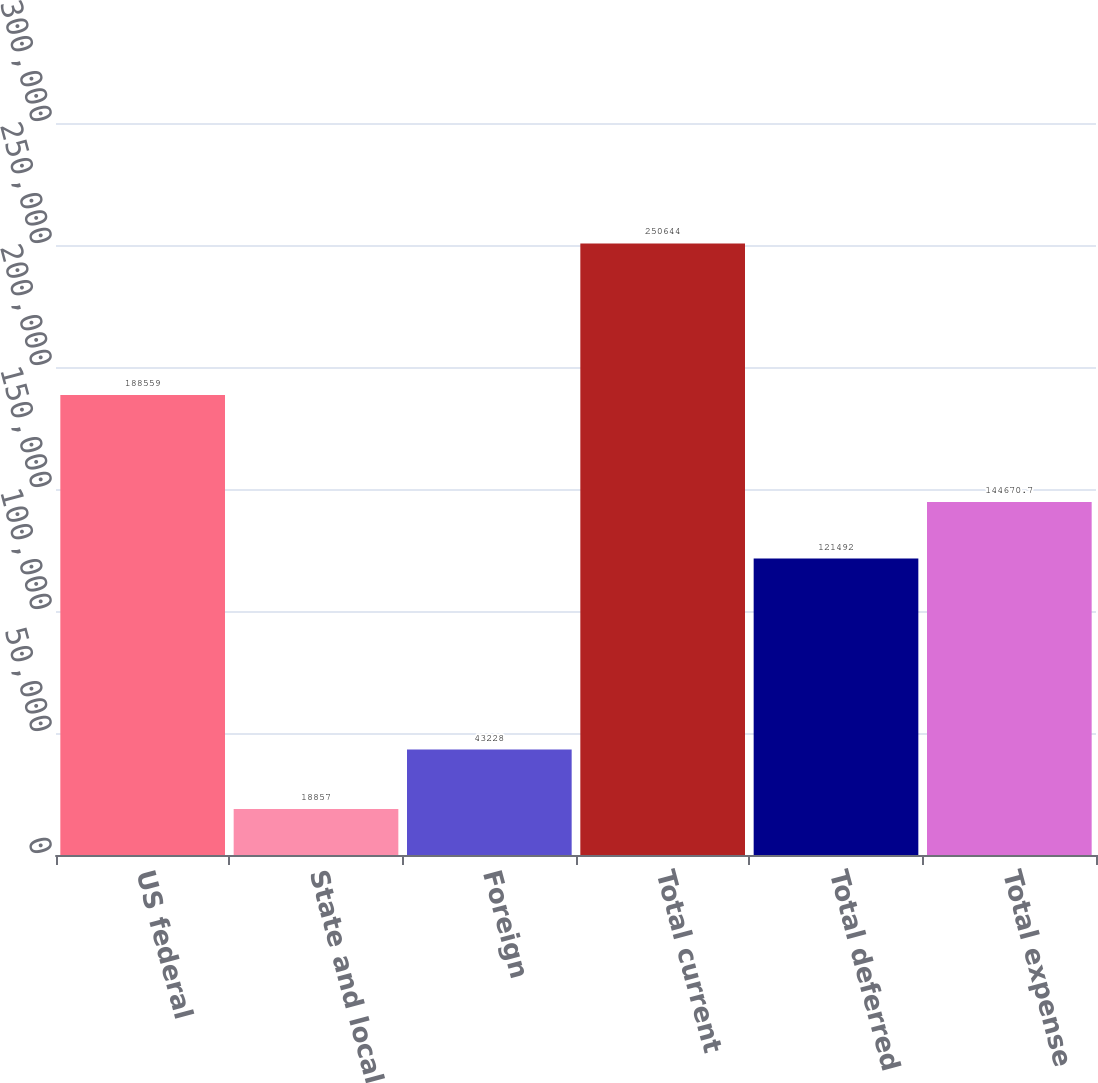Convert chart to OTSL. <chart><loc_0><loc_0><loc_500><loc_500><bar_chart><fcel>US federal<fcel>State and local<fcel>Foreign<fcel>Total current<fcel>Total deferred<fcel>Total expense<nl><fcel>188559<fcel>18857<fcel>43228<fcel>250644<fcel>121492<fcel>144671<nl></chart> 